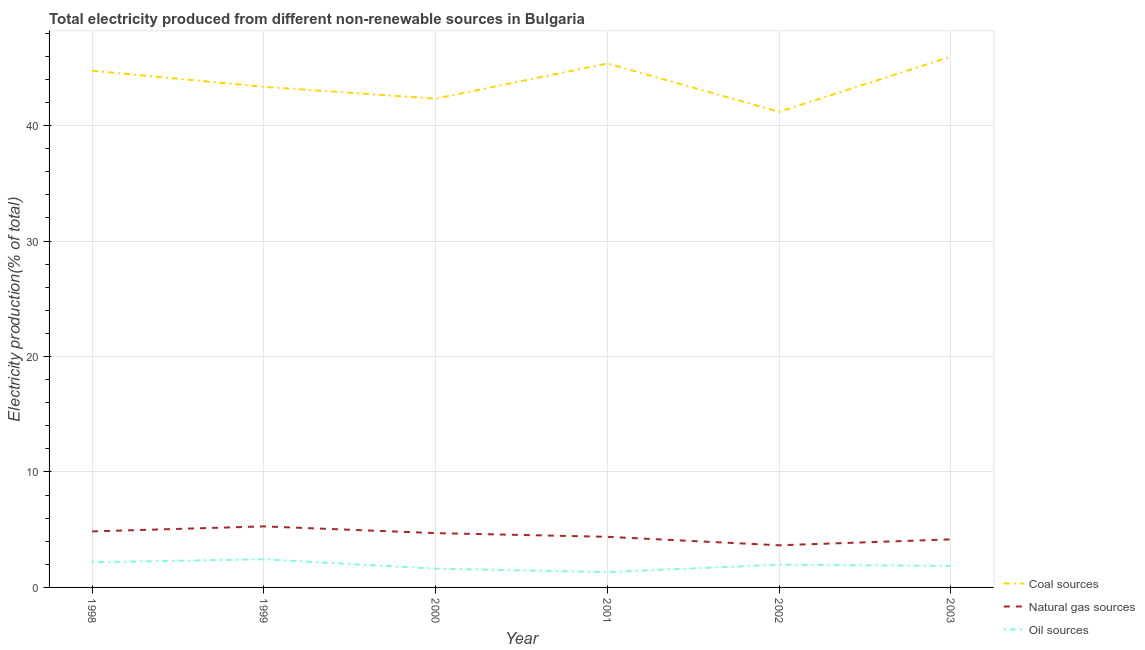Does the line corresponding to percentage of electricity produced by coal intersect with the line corresponding to percentage of electricity produced by natural gas?
Your answer should be compact. No. What is the percentage of electricity produced by natural gas in 1999?
Your response must be concise. 5.29. Across all years, what is the maximum percentage of electricity produced by oil sources?
Ensure brevity in your answer.  2.44. Across all years, what is the minimum percentage of electricity produced by coal?
Offer a very short reply. 41.2. In which year was the percentage of electricity produced by natural gas maximum?
Ensure brevity in your answer.  1999. In which year was the percentage of electricity produced by coal minimum?
Provide a succinct answer. 2002. What is the total percentage of electricity produced by natural gas in the graph?
Your answer should be compact. 27.04. What is the difference between the percentage of electricity produced by oil sources in 2000 and that in 2001?
Your answer should be very brief. 0.3. What is the difference between the percentage of electricity produced by coal in 2002 and the percentage of electricity produced by natural gas in 2003?
Offer a very short reply. 37.04. What is the average percentage of electricity produced by oil sources per year?
Provide a succinct answer. 1.9. In the year 2001, what is the difference between the percentage of electricity produced by natural gas and percentage of electricity produced by oil sources?
Make the answer very short. 3.05. What is the ratio of the percentage of electricity produced by coal in 1999 to that in 2000?
Offer a very short reply. 1.02. Is the percentage of electricity produced by natural gas in 1998 less than that in 2003?
Keep it short and to the point. No. What is the difference between the highest and the second highest percentage of electricity produced by oil sources?
Make the answer very short. 0.26. What is the difference between the highest and the lowest percentage of electricity produced by natural gas?
Provide a succinct answer. 1.64. Is the sum of the percentage of electricity produced by oil sources in 2002 and 2003 greater than the maximum percentage of electricity produced by natural gas across all years?
Provide a succinct answer. No. Is it the case that in every year, the sum of the percentage of electricity produced by coal and percentage of electricity produced by natural gas is greater than the percentage of electricity produced by oil sources?
Make the answer very short. Yes. Does the percentage of electricity produced by coal monotonically increase over the years?
Your answer should be compact. No. Is the percentage of electricity produced by coal strictly less than the percentage of electricity produced by oil sources over the years?
Your response must be concise. No. How many lines are there?
Your answer should be very brief. 3. How many years are there in the graph?
Give a very brief answer. 6. How many legend labels are there?
Ensure brevity in your answer.  3. What is the title of the graph?
Your answer should be compact. Total electricity produced from different non-renewable sources in Bulgaria. Does "Ages 20-60" appear as one of the legend labels in the graph?
Provide a short and direct response. No. What is the label or title of the X-axis?
Provide a short and direct response. Year. What is the Electricity production(% of total) in Coal sources in 1998?
Your answer should be compact. 44.76. What is the Electricity production(% of total) in Natural gas sources in 1998?
Your response must be concise. 4.85. What is the Electricity production(% of total) in Oil sources in 1998?
Provide a succinct answer. 2.18. What is the Electricity production(% of total) of Coal sources in 1999?
Offer a very short reply. 43.36. What is the Electricity production(% of total) in Natural gas sources in 1999?
Ensure brevity in your answer.  5.29. What is the Electricity production(% of total) in Oil sources in 1999?
Your answer should be compact. 2.44. What is the Electricity production(% of total) of Coal sources in 2000?
Offer a terse response. 42.33. What is the Electricity production(% of total) in Natural gas sources in 2000?
Provide a short and direct response. 4.7. What is the Electricity production(% of total) in Oil sources in 2000?
Offer a terse response. 1.63. What is the Electricity production(% of total) of Coal sources in 2001?
Keep it short and to the point. 45.38. What is the Electricity production(% of total) in Natural gas sources in 2001?
Provide a succinct answer. 4.38. What is the Electricity production(% of total) of Oil sources in 2001?
Your response must be concise. 1.33. What is the Electricity production(% of total) of Coal sources in 2002?
Your answer should be compact. 41.2. What is the Electricity production(% of total) of Natural gas sources in 2002?
Your answer should be very brief. 3.65. What is the Electricity production(% of total) of Oil sources in 2002?
Your response must be concise. 1.97. What is the Electricity production(% of total) in Coal sources in 2003?
Keep it short and to the point. 45.98. What is the Electricity production(% of total) of Natural gas sources in 2003?
Provide a short and direct response. 4.16. What is the Electricity production(% of total) of Oil sources in 2003?
Make the answer very short. 1.86. Across all years, what is the maximum Electricity production(% of total) in Coal sources?
Give a very brief answer. 45.98. Across all years, what is the maximum Electricity production(% of total) of Natural gas sources?
Ensure brevity in your answer.  5.29. Across all years, what is the maximum Electricity production(% of total) in Oil sources?
Give a very brief answer. 2.44. Across all years, what is the minimum Electricity production(% of total) in Coal sources?
Offer a very short reply. 41.2. Across all years, what is the minimum Electricity production(% of total) in Natural gas sources?
Your response must be concise. 3.65. Across all years, what is the minimum Electricity production(% of total) in Oil sources?
Keep it short and to the point. 1.33. What is the total Electricity production(% of total) in Coal sources in the graph?
Make the answer very short. 263.01. What is the total Electricity production(% of total) of Natural gas sources in the graph?
Your response must be concise. 27.04. What is the total Electricity production(% of total) in Oil sources in the graph?
Your response must be concise. 11.41. What is the difference between the Electricity production(% of total) in Coal sources in 1998 and that in 1999?
Your answer should be compact. 1.4. What is the difference between the Electricity production(% of total) of Natural gas sources in 1998 and that in 1999?
Provide a succinct answer. -0.43. What is the difference between the Electricity production(% of total) in Oil sources in 1998 and that in 1999?
Your answer should be very brief. -0.26. What is the difference between the Electricity production(% of total) in Coal sources in 1998 and that in 2000?
Make the answer very short. 2.42. What is the difference between the Electricity production(% of total) in Natural gas sources in 1998 and that in 2000?
Your answer should be compact. 0.15. What is the difference between the Electricity production(% of total) of Oil sources in 1998 and that in 2000?
Your response must be concise. 0.56. What is the difference between the Electricity production(% of total) of Coal sources in 1998 and that in 2001?
Your answer should be compact. -0.62. What is the difference between the Electricity production(% of total) of Natural gas sources in 1998 and that in 2001?
Make the answer very short. 0.47. What is the difference between the Electricity production(% of total) in Oil sources in 1998 and that in 2001?
Give a very brief answer. 0.85. What is the difference between the Electricity production(% of total) of Coal sources in 1998 and that in 2002?
Give a very brief answer. 3.56. What is the difference between the Electricity production(% of total) in Natural gas sources in 1998 and that in 2002?
Offer a terse response. 1.2. What is the difference between the Electricity production(% of total) of Oil sources in 1998 and that in 2002?
Make the answer very short. 0.21. What is the difference between the Electricity production(% of total) of Coal sources in 1998 and that in 2003?
Offer a very short reply. -1.22. What is the difference between the Electricity production(% of total) in Natural gas sources in 1998 and that in 2003?
Make the answer very short. 0.69. What is the difference between the Electricity production(% of total) of Oil sources in 1998 and that in 2003?
Make the answer very short. 0.32. What is the difference between the Electricity production(% of total) of Coal sources in 1999 and that in 2000?
Provide a short and direct response. 1.03. What is the difference between the Electricity production(% of total) in Natural gas sources in 1999 and that in 2000?
Your answer should be compact. 0.58. What is the difference between the Electricity production(% of total) of Oil sources in 1999 and that in 2000?
Offer a terse response. 0.81. What is the difference between the Electricity production(% of total) in Coal sources in 1999 and that in 2001?
Offer a terse response. -2.02. What is the difference between the Electricity production(% of total) in Natural gas sources in 1999 and that in 2001?
Provide a short and direct response. 0.9. What is the difference between the Electricity production(% of total) in Oil sources in 1999 and that in 2001?
Offer a very short reply. 1.11. What is the difference between the Electricity production(% of total) in Coal sources in 1999 and that in 2002?
Give a very brief answer. 2.16. What is the difference between the Electricity production(% of total) in Natural gas sources in 1999 and that in 2002?
Provide a short and direct response. 1.64. What is the difference between the Electricity production(% of total) of Oil sources in 1999 and that in 2002?
Provide a short and direct response. 0.47. What is the difference between the Electricity production(% of total) in Coal sources in 1999 and that in 2003?
Your response must be concise. -2.62. What is the difference between the Electricity production(% of total) in Natural gas sources in 1999 and that in 2003?
Your answer should be very brief. 1.12. What is the difference between the Electricity production(% of total) in Oil sources in 1999 and that in 2003?
Offer a very short reply. 0.57. What is the difference between the Electricity production(% of total) in Coal sources in 2000 and that in 2001?
Keep it short and to the point. -3.05. What is the difference between the Electricity production(% of total) in Natural gas sources in 2000 and that in 2001?
Provide a short and direct response. 0.32. What is the difference between the Electricity production(% of total) in Oil sources in 2000 and that in 2001?
Your answer should be compact. 0.3. What is the difference between the Electricity production(% of total) in Coal sources in 2000 and that in 2002?
Offer a terse response. 1.14. What is the difference between the Electricity production(% of total) in Natural gas sources in 2000 and that in 2002?
Provide a succinct answer. 1.05. What is the difference between the Electricity production(% of total) of Oil sources in 2000 and that in 2002?
Make the answer very short. -0.34. What is the difference between the Electricity production(% of total) of Coal sources in 2000 and that in 2003?
Give a very brief answer. -3.65. What is the difference between the Electricity production(% of total) in Natural gas sources in 2000 and that in 2003?
Make the answer very short. 0.54. What is the difference between the Electricity production(% of total) of Oil sources in 2000 and that in 2003?
Offer a very short reply. -0.24. What is the difference between the Electricity production(% of total) in Coal sources in 2001 and that in 2002?
Provide a succinct answer. 4.18. What is the difference between the Electricity production(% of total) of Natural gas sources in 2001 and that in 2002?
Ensure brevity in your answer.  0.73. What is the difference between the Electricity production(% of total) of Oil sources in 2001 and that in 2002?
Ensure brevity in your answer.  -0.64. What is the difference between the Electricity production(% of total) of Coal sources in 2001 and that in 2003?
Offer a very short reply. -0.6. What is the difference between the Electricity production(% of total) of Natural gas sources in 2001 and that in 2003?
Give a very brief answer. 0.22. What is the difference between the Electricity production(% of total) of Oil sources in 2001 and that in 2003?
Ensure brevity in your answer.  -0.53. What is the difference between the Electricity production(% of total) of Coal sources in 2002 and that in 2003?
Keep it short and to the point. -4.78. What is the difference between the Electricity production(% of total) of Natural gas sources in 2002 and that in 2003?
Provide a short and direct response. -0.51. What is the difference between the Electricity production(% of total) in Oil sources in 2002 and that in 2003?
Ensure brevity in your answer.  0.1. What is the difference between the Electricity production(% of total) in Coal sources in 1998 and the Electricity production(% of total) in Natural gas sources in 1999?
Offer a very short reply. 39.47. What is the difference between the Electricity production(% of total) of Coal sources in 1998 and the Electricity production(% of total) of Oil sources in 1999?
Make the answer very short. 42.32. What is the difference between the Electricity production(% of total) in Natural gas sources in 1998 and the Electricity production(% of total) in Oil sources in 1999?
Ensure brevity in your answer.  2.41. What is the difference between the Electricity production(% of total) of Coal sources in 1998 and the Electricity production(% of total) of Natural gas sources in 2000?
Ensure brevity in your answer.  40.05. What is the difference between the Electricity production(% of total) of Coal sources in 1998 and the Electricity production(% of total) of Oil sources in 2000?
Your response must be concise. 43.13. What is the difference between the Electricity production(% of total) of Natural gas sources in 1998 and the Electricity production(% of total) of Oil sources in 2000?
Keep it short and to the point. 3.23. What is the difference between the Electricity production(% of total) of Coal sources in 1998 and the Electricity production(% of total) of Natural gas sources in 2001?
Offer a terse response. 40.38. What is the difference between the Electricity production(% of total) in Coal sources in 1998 and the Electricity production(% of total) in Oil sources in 2001?
Your answer should be compact. 43.43. What is the difference between the Electricity production(% of total) of Natural gas sources in 1998 and the Electricity production(% of total) of Oil sources in 2001?
Ensure brevity in your answer.  3.52. What is the difference between the Electricity production(% of total) of Coal sources in 1998 and the Electricity production(% of total) of Natural gas sources in 2002?
Your answer should be compact. 41.11. What is the difference between the Electricity production(% of total) of Coal sources in 1998 and the Electricity production(% of total) of Oil sources in 2002?
Provide a succinct answer. 42.79. What is the difference between the Electricity production(% of total) of Natural gas sources in 1998 and the Electricity production(% of total) of Oil sources in 2002?
Offer a terse response. 2.88. What is the difference between the Electricity production(% of total) in Coal sources in 1998 and the Electricity production(% of total) in Natural gas sources in 2003?
Your response must be concise. 40.6. What is the difference between the Electricity production(% of total) in Coal sources in 1998 and the Electricity production(% of total) in Oil sources in 2003?
Your answer should be compact. 42.89. What is the difference between the Electricity production(% of total) of Natural gas sources in 1998 and the Electricity production(% of total) of Oil sources in 2003?
Give a very brief answer. 2.99. What is the difference between the Electricity production(% of total) in Coal sources in 1999 and the Electricity production(% of total) in Natural gas sources in 2000?
Keep it short and to the point. 38.66. What is the difference between the Electricity production(% of total) in Coal sources in 1999 and the Electricity production(% of total) in Oil sources in 2000?
Your answer should be very brief. 41.74. What is the difference between the Electricity production(% of total) of Natural gas sources in 1999 and the Electricity production(% of total) of Oil sources in 2000?
Your response must be concise. 3.66. What is the difference between the Electricity production(% of total) in Coal sources in 1999 and the Electricity production(% of total) in Natural gas sources in 2001?
Provide a succinct answer. 38.98. What is the difference between the Electricity production(% of total) in Coal sources in 1999 and the Electricity production(% of total) in Oil sources in 2001?
Offer a terse response. 42.03. What is the difference between the Electricity production(% of total) of Natural gas sources in 1999 and the Electricity production(% of total) of Oil sources in 2001?
Your response must be concise. 3.96. What is the difference between the Electricity production(% of total) in Coal sources in 1999 and the Electricity production(% of total) in Natural gas sources in 2002?
Make the answer very short. 39.71. What is the difference between the Electricity production(% of total) in Coal sources in 1999 and the Electricity production(% of total) in Oil sources in 2002?
Your answer should be very brief. 41.39. What is the difference between the Electricity production(% of total) in Natural gas sources in 1999 and the Electricity production(% of total) in Oil sources in 2002?
Your response must be concise. 3.32. What is the difference between the Electricity production(% of total) of Coal sources in 1999 and the Electricity production(% of total) of Natural gas sources in 2003?
Keep it short and to the point. 39.2. What is the difference between the Electricity production(% of total) of Coal sources in 1999 and the Electricity production(% of total) of Oil sources in 2003?
Keep it short and to the point. 41.5. What is the difference between the Electricity production(% of total) of Natural gas sources in 1999 and the Electricity production(% of total) of Oil sources in 2003?
Provide a succinct answer. 3.42. What is the difference between the Electricity production(% of total) of Coal sources in 2000 and the Electricity production(% of total) of Natural gas sources in 2001?
Your response must be concise. 37.95. What is the difference between the Electricity production(% of total) in Coal sources in 2000 and the Electricity production(% of total) in Oil sources in 2001?
Your response must be concise. 41. What is the difference between the Electricity production(% of total) of Natural gas sources in 2000 and the Electricity production(% of total) of Oil sources in 2001?
Offer a very short reply. 3.37. What is the difference between the Electricity production(% of total) in Coal sources in 2000 and the Electricity production(% of total) in Natural gas sources in 2002?
Offer a terse response. 38.68. What is the difference between the Electricity production(% of total) of Coal sources in 2000 and the Electricity production(% of total) of Oil sources in 2002?
Offer a terse response. 40.37. What is the difference between the Electricity production(% of total) in Natural gas sources in 2000 and the Electricity production(% of total) in Oil sources in 2002?
Make the answer very short. 2.74. What is the difference between the Electricity production(% of total) of Coal sources in 2000 and the Electricity production(% of total) of Natural gas sources in 2003?
Offer a very short reply. 38.17. What is the difference between the Electricity production(% of total) in Coal sources in 2000 and the Electricity production(% of total) in Oil sources in 2003?
Provide a short and direct response. 40.47. What is the difference between the Electricity production(% of total) in Natural gas sources in 2000 and the Electricity production(% of total) in Oil sources in 2003?
Give a very brief answer. 2.84. What is the difference between the Electricity production(% of total) in Coal sources in 2001 and the Electricity production(% of total) in Natural gas sources in 2002?
Offer a very short reply. 41.73. What is the difference between the Electricity production(% of total) in Coal sources in 2001 and the Electricity production(% of total) in Oil sources in 2002?
Your response must be concise. 43.41. What is the difference between the Electricity production(% of total) in Natural gas sources in 2001 and the Electricity production(% of total) in Oil sources in 2002?
Ensure brevity in your answer.  2.41. What is the difference between the Electricity production(% of total) in Coal sources in 2001 and the Electricity production(% of total) in Natural gas sources in 2003?
Make the answer very short. 41.22. What is the difference between the Electricity production(% of total) in Coal sources in 2001 and the Electricity production(% of total) in Oil sources in 2003?
Offer a terse response. 43.52. What is the difference between the Electricity production(% of total) of Natural gas sources in 2001 and the Electricity production(% of total) of Oil sources in 2003?
Your response must be concise. 2.52. What is the difference between the Electricity production(% of total) of Coal sources in 2002 and the Electricity production(% of total) of Natural gas sources in 2003?
Offer a terse response. 37.04. What is the difference between the Electricity production(% of total) of Coal sources in 2002 and the Electricity production(% of total) of Oil sources in 2003?
Offer a terse response. 39.33. What is the difference between the Electricity production(% of total) of Natural gas sources in 2002 and the Electricity production(% of total) of Oil sources in 2003?
Offer a very short reply. 1.79. What is the average Electricity production(% of total) in Coal sources per year?
Offer a terse response. 43.84. What is the average Electricity production(% of total) of Natural gas sources per year?
Your answer should be very brief. 4.51. What is the average Electricity production(% of total) in Oil sources per year?
Make the answer very short. 1.9. In the year 1998, what is the difference between the Electricity production(% of total) in Coal sources and Electricity production(% of total) in Natural gas sources?
Your answer should be very brief. 39.91. In the year 1998, what is the difference between the Electricity production(% of total) of Coal sources and Electricity production(% of total) of Oil sources?
Your response must be concise. 42.58. In the year 1998, what is the difference between the Electricity production(% of total) in Natural gas sources and Electricity production(% of total) in Oil sources?
Offer a terse response. 2.67. In the year 1999, what is the difference between the Electricity production(% of total) in Coal sources and Electricity production(% of total) in Natural gas sources?
Give a very brief answer. 38.08. In the year 1999, what is the difference between the Electricity production(% of total) of Coal sources and Electricity production(% of total) of Oil sources?
Your answer should be compact. 40.92. In the year 1999, what is the difference between the Electricity production(% of total) of Natural gas sources and Electricity production(% of total) of Oil sources?
Offer a terse response. 2.85. In the year 2000, what is the difference between the Electricity production(% of total) of Coal sources and Electricity production(% of total) of Natural gas sources?
Give a very brief answer. 37.63. In the year 2000, what is the difference between the Electricity production(% of total) in Coal sources and Electricity production(% of total) in Oil sources?
Keep it short and to the point. 40.71. In the year 2000, what is the difference between the Electricity production(% of total) in Natural gas sources and Electricity production(% of total) in Oil sources?
Give a very brief answer. 3.08. In the year 2001, what is the difference between the Electricity production(% of total) of Coal sources and Electricity production(% of total) of Natural gas sources?
Give a very brief answer. 41. In the year 2001, what is the difference between the Electricity production(% of total) of Coal sources and Electricity production(% of total) of Oil sources?
Give a very brief answer. 44.05. In the year 2001, what is the difference between the Electricity production(% of total) in Natural gas sources and Electricity production(% of total) in Oil sources?
Ensure brevity in your answer.  3.05. In the year 2002, what is the difference between the Electricity production(% of total) in Coal sources and Electricity production(% of total) in Natural gas sources?
Your response must be concise. 37.55. In the year 2002, what is the difference between the Electricity production(% of total) of Coal sources and Electricity production(% of total) of Oil sources?
Offer a terse response. 39.23. In the year 2002, what is the difference between the Electricity production(% of total) of Natural gas sources and Electricity production(% of total) of Oil sources?
Give a very brief answer. 1.68. In the year 2003, what is the difference between the Electricity production(% of total) in Coal sources and Electricity production(% of total) in Natural gas sources?
Keep it short and to the point. 41.82. In the year 2003, what is the difference between the Electricity production(% of total) in Coal sources and Electricity production(% of total) in Oil sources?
Your answer should be very brief. 44.12. In the year 2003, what is the difference between the Electricity production(% of total) of Natural gas sources and Electricity production(% of total) of Oil sources?
Your answer should be compact. 2.3. What is the ratio of the Electricity production(% of total) in Coal sources in 1998 to that in 1999?
Give a very brief answer. 1.03. What is the ratio of the Electricity production(% of total) in Natural gas sources in 1998 to that in 1999?
Your answer should be compact. 0.92. What is the ratio of the Electricity production(% of total) in Oil sources in 1998 to that in 1999?
Make the answer very short. 0.89. What is the ratio of the Electricity production(% of total) of Coal sources in 1998 to that in 2000?
Ensure brevity in your answer.  1.06. What is the ratio of the Electricity production(% of total) of Natural gas sources in 1998 to that in 2000?
Provide a succinct answer. 1.03. What is the ratio of the Electricity production(% of total) in Oil sources in 1998 to that in 2000?
Provide a succinct answer. 1.34. What is the ratio of the Electricity production(% of total) of Coal sources in 1998 to that in 2001?
Your response must be concise. 0.99. What is the ratio of the Electricity production(% of total) of Natural gas sources in 1998 to that in 2001?
Give a very brief answer. 1.11. What is the ratio of the Electricity production(% of total) of Oil sources in 1998 to that in 2001?
Keep it short and to the point. 1.64. What is the ratio of the Electricity production(% of total) of Coal sources in 1998 to that in 2002?
Offer a terse response. 1.09. What is the ratio of the Electricity production(% of total) in Natural gas sources in 1998 to that in 2002?
Offer a very short reply. 1.33. What is the ratio of the Electricity production(% of total) of Oil sources in 1998 to that in 2002?
Your response must be concise. 1.11. What is the ratio of the Electricity production(% of total) in Coal sources in 1998 to that in 2003?
Give a very brief answer. 0.97. What is the ratio of the Electricity production(% of total) in Natural gas sources in 1998 to that in 2003?
Your answer should be very brief. 1.17. What is the ratio of the Electricity production(% of total) of Oil sources in 1998 to that in 2003?
Offer a very short reply. 1.17. What is the ratio of the Electricity production(% of total) of Coal sources in 1999 to that in 2000?
Offer a terse response. 1.02. What is the ratio of the Electricity production(% of total) of Natural gas sources in 1999 to that in 2000?
Ensure brevity in your answer.  1.12. What is the ratio of the Electricity production(% of total) of Oil sources in 1999 to that in 2000?
Your answer should be compact. 1.5. What is the ratio of the Electricity production(% of total) of Coal sources in 1999 to that in 2001?
Your answer should be compact. 0.96. What is the ratio of the Electricity production(% of total) in Natural gas sources in 1999 to that in 2001?
Offer a terse response. 1.21. What is the ratio of the Electricity production(% of total) of Oil sources in 1999 to that in 2001?
Give a very brief answer. 1.83. What is the ratio of the Electricity production(% of total) in Coal sources in 1999 to that in 2002?
Offer a very short reply. 1.05. What is the ratio of the Electricity production(% of total) of Natural gas sources in 1999 to that in 2002?
Your response must be concise. 1.45. What is the ratio of the Electricity production(% of total) in Oil sources in 1999 to that in 2002?
Ensure brevity in your answer.  1.24. What is the ratio of the Electricity production(% of total) in Coal sources in 1999 to that in 2003?
Keep it short and to the point. 0.94. What is the ratio of the Electricity production(% of total) in Natural gas sources in 1999 to that in 2003?
Your response must be concise. 1.27. What is the ratio of the Electricity production(% of total) of Oil sources in 1999 to that in 2003?
Give a very brief answer. 1.31. What is the ratio of the Electricity production(% of total) in Coal sources in 2000 to that in 2001?
Offer a very short reply. 0.93. What is the ratio of the Electricity production(% of total) of Natural gas sources in 2000 to that in 2001?
Keep it short and to the point. 1.07. What is the ratio of the Electricity production(% of total) in Oil sources in 2000 to that in 2001?
Provide a succinct answer. 1.22. What is the ratio of the Electricity production(% of total) of Coal sources in 2000 to that in 2002?
Provide a short and direct response. 1.03. What is the ratio of the Electricity production(% of total) in Natural gas sources in 2000 to that in 2002?
Your answer should be compact. 1.29. What is the ratio of the Electricity production(% of total) in Oil sources in 2000 to that in 2002?
Your answer should be very brief. 0.83. What is the ratio of the Electricity production(% of total) in Coal sources in 2000 to that in 2003?
Provide a short and direct response. 0.92. What is the ratio of the Electricity production(% of total) in Natural gas sources in 2000 to that in 2003?
Provide a short and direct response. 1.13. What is the ratio of the Electricity production(% of total) in Oil sources in 2000 to that in 2003?
Your answer should be compact. 0.87. What is the ratio of the Electricity production(% of total) in Coal sources in 2001 to that in 2002?
Provide a short and direct response. 1.1. What is the ratio of the Electricity production(% of total) of Natural gas sources in 2001 to that in 2002?
Your answer should be very brief. 1.2. What is the ratio of the Electricity production(% of total) of Oil sources in 2001 to that in 2002?
Make the answer very short. 0.68. What is the ratio of the Electricity production(% of total) of Coal sources in 2001 to that in 2003?
Offer a terse response. 0.99. What is the ratio of the Electricity production(% of total) of Natural gas sources in 2001 to that in 2003?
Give a very brief answer. 1.05. What is the ratio of the Electricity production(% of total) of Oil sources in 2001 to that in 2003?
Your answer should be compact. 0.71. What is the ratio of the Electricity production(% of total) of Coal sources in 2002 to that in 2003?
Make the answer very short. 0.9. What is the ratio of the Electricity production(% of total) of Natural gas sources in 2002 to that in 2003?
Ensure brevity in your answer.  0.88. What is the ratio of the Electricity production(% of total) in Oil sources in 2002 to that in 2003?
Offer a very short reply. 1.06. What is the difference between the highest and the second highest Electricity production(% of total) in Coal sources?
Make the answer very short. 0.6. What is the difference between the highest and the second highest Electricity production(% of total) in Natural gas sources?
Your response must be concise. 0.43. What is the difference between the highest and the second highest Electricity production(% of total) of Oil sources?
Keep it short and to the point. 0.26. What is the difference between the highest and the lowest Electricity production(% of total) of Coal sources?
Give a very brief answer. 4.78. What is the difference between the highest and the lowest Electricity production(% of total) of Natural gas sources?
Offer a very short reply. 1.64. What is the difference between the highest and the lowest Electricity production(% of total) in Oil sources?
Your answer should be very brief. 1.11. 